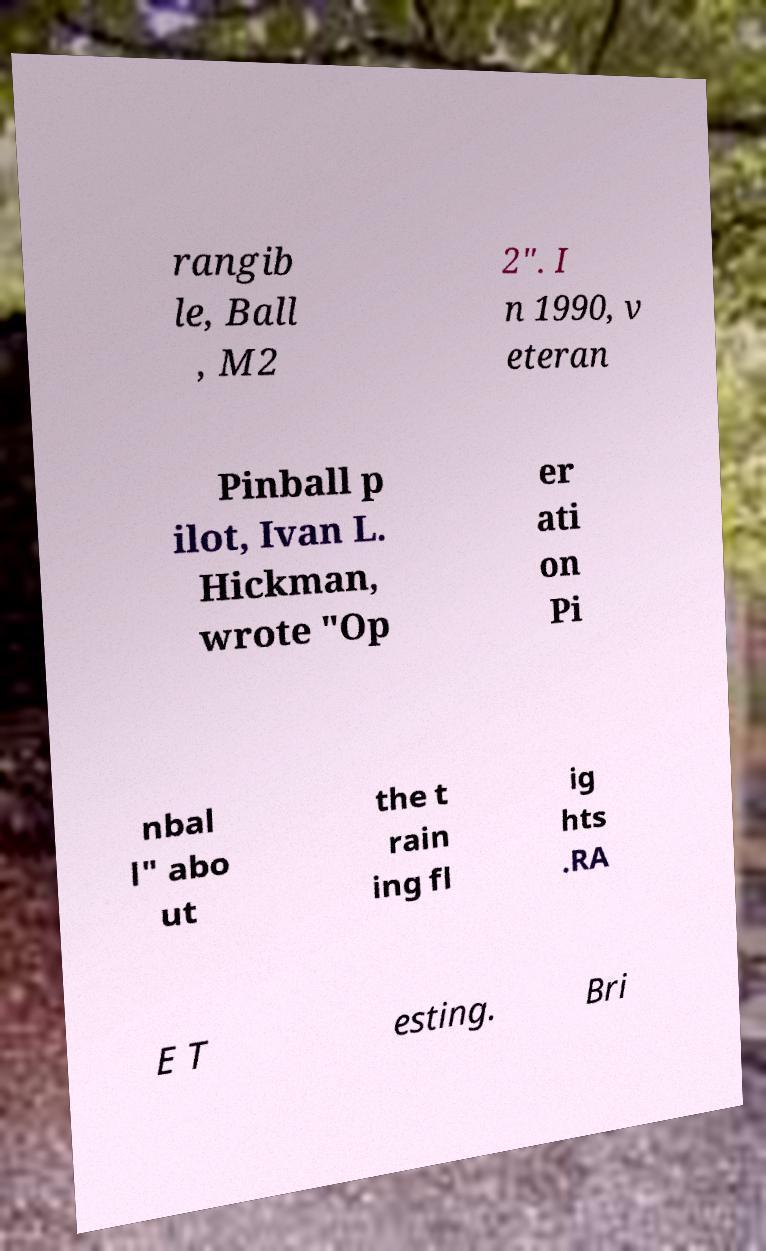There's text embedded in this image that I need extracted. Can you transcribe it verbatim? rangib le, Ball , M2 2". I n 1990, v eteran Pinball p ilot, Ivan L. Hickman, wrote "Op er ati on Pi nbal l" abo ut the t rain ing fl ig hts .RA E T esting. Bri 